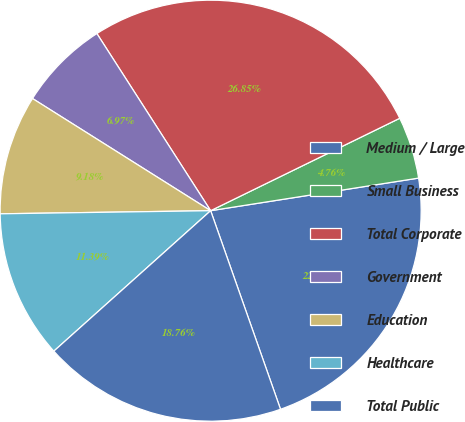Convert chart. <chart><loc_0><loc_0><loc_500><loc_500><pie_chart><fcel>Medium / Large<fcel>Small Business<fcel>Total Corporate<fcel>Government<fcel>Education<fcel>Healthcare<fcel>Total Public<nl><fcel>22.09%<fcel>4.76%<fcel>26.85%<fcel>6.97%<fcel>9.18%<fcel>11.39%<fcel>18.76%<nl></chart> 